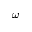<formula> <loc_0><loc_0><loc_500><loc_500>\omega</formula> 